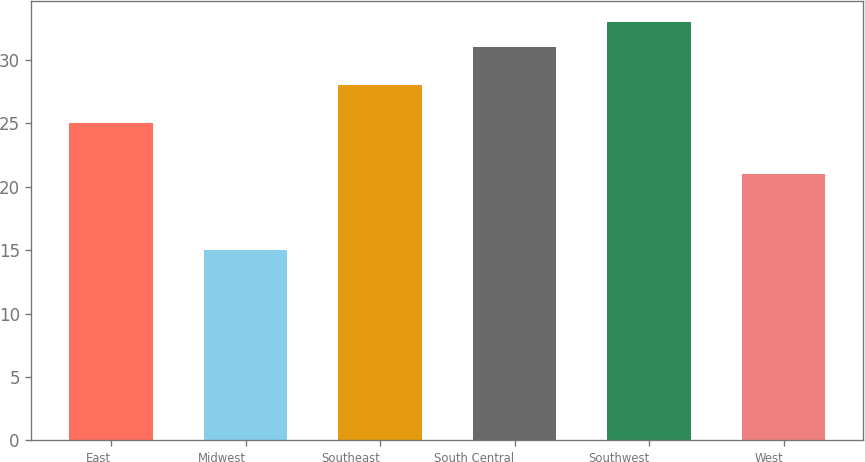Convert chart. <chart><loc_0><loc_0><loc_500><loc_500><bar_chart><fcel>East<fcel>Midwest<fcel>Southeast<fcel>South Central<fcel>Southwest<fcel>West<nl><fcel>25<fcel>15<fcel>28<fcel>31<fcel>33<fcel>21<nl></chart> 